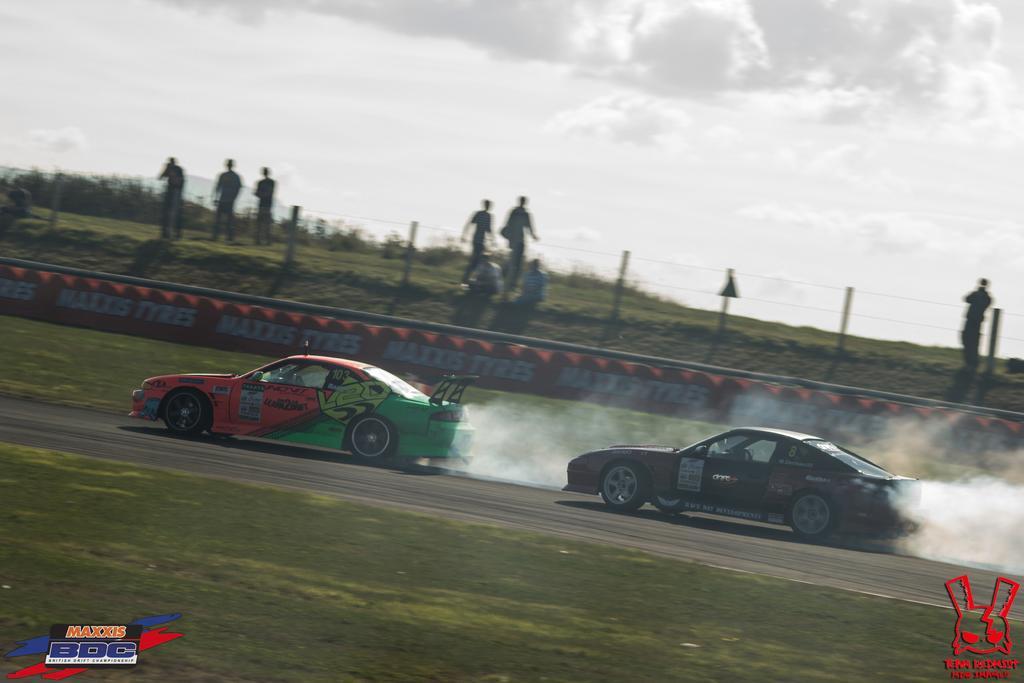Please provide a concise description of this image. In the image there are two cars moving on the road and they are emitting some smoke, behind the cars there is a fencing and behind the fencing there are few people. 